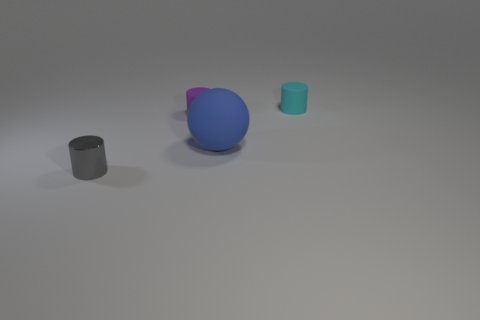Subtract all tiny purple cylinders. How many cylinders are left? 2 Add 2 rubber objects. How many objects exist? 6 Subtract 3 cylinders. How many cylinders are left? 0 Subtract all purple cylinders. How many cylinders are left? 2 Subtract all cylinders. How many objects are left? 1 Subtract all blue cubes. How many cyan cylinders are left? 1 Subtract all small cyan cylinders. Subtract all small purple rubber things. How many objects are left? 2 Add 2 purple cylinders. How many purple cylinders are left? 3 Add 3 tiny things. How many tiny things exist? 6 Subtract 1 cyan cylinders. How many objects are left? 3 